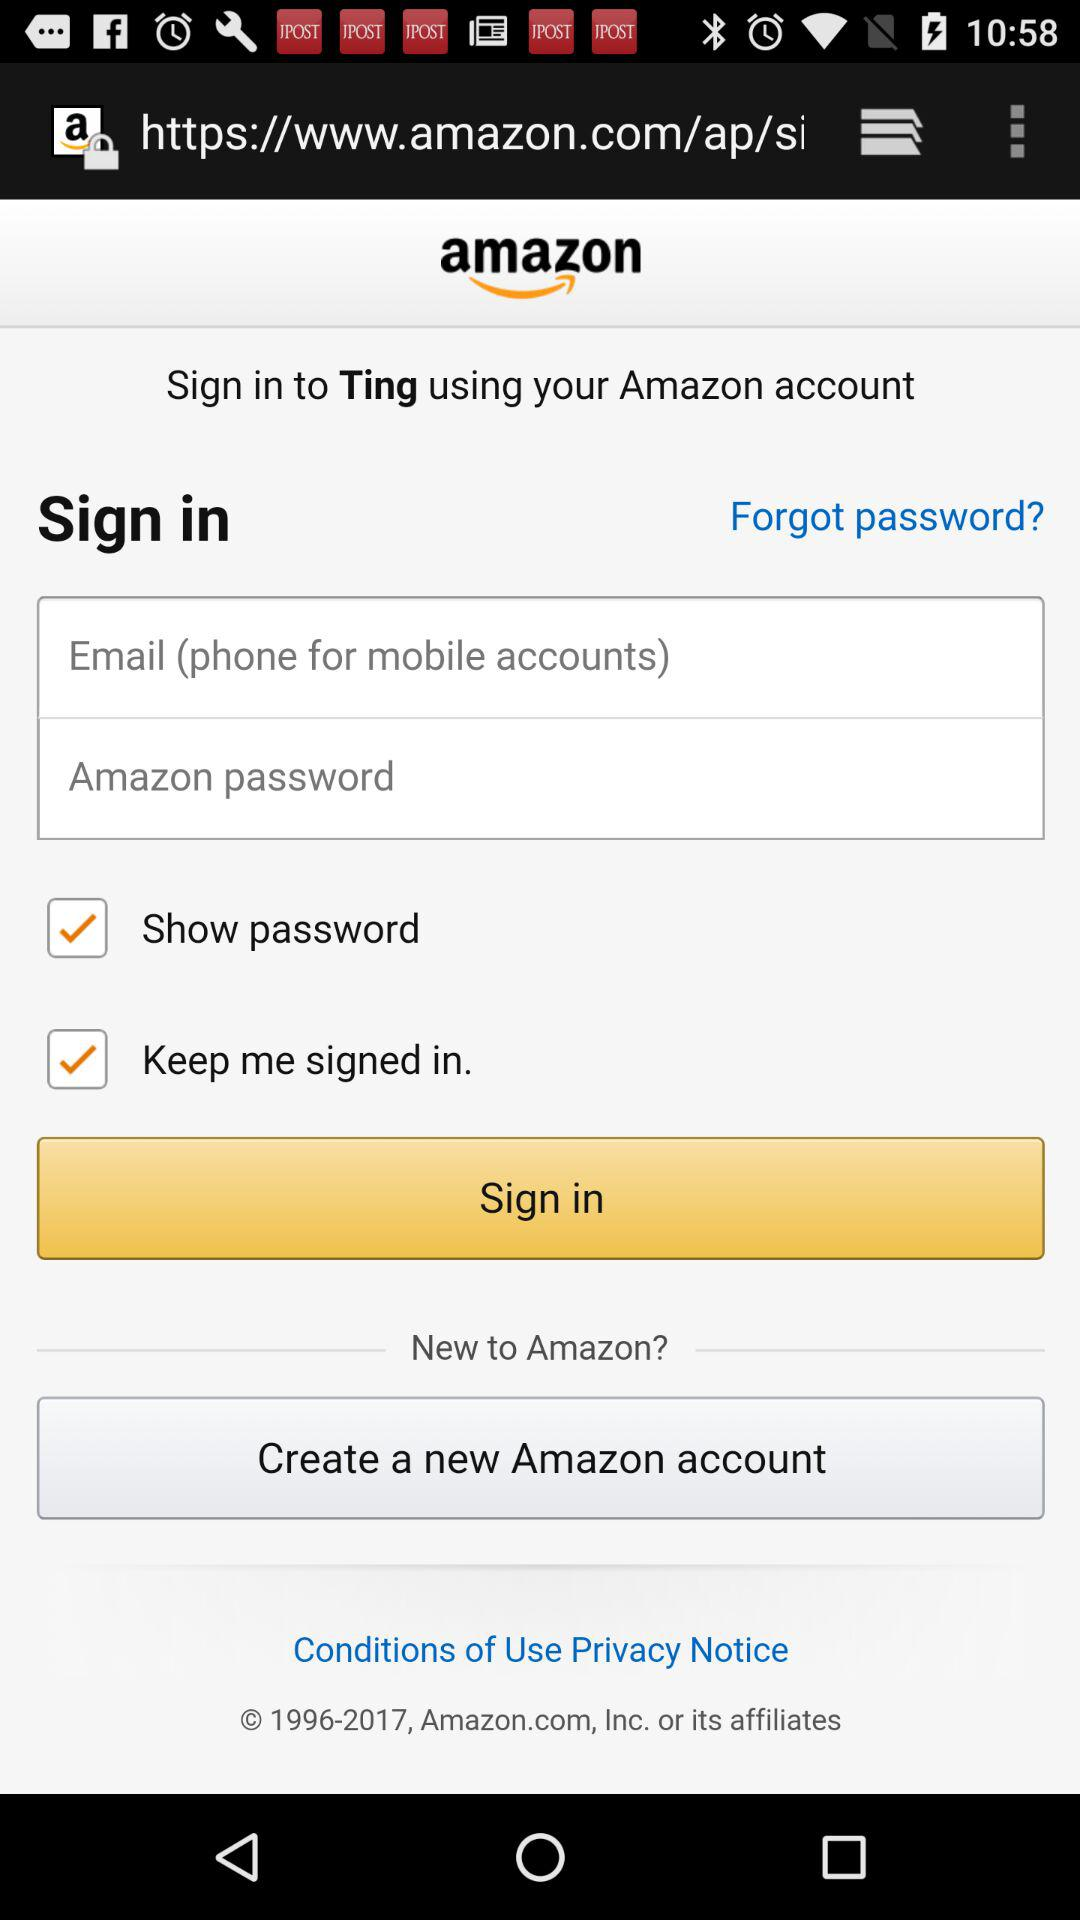Can signing in to "Ting" be accomplished through another application?
When the provided information is insufficient, respond with <no answer>. <no answer> 